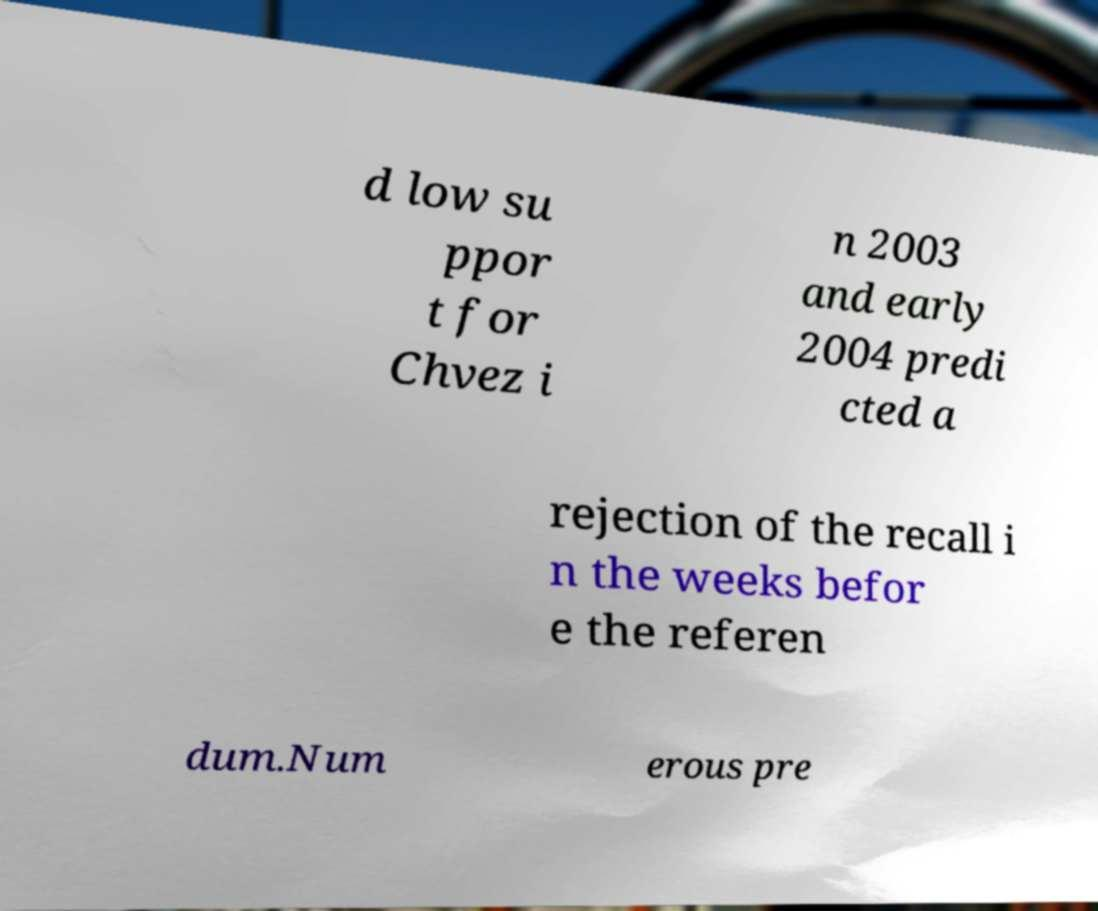Please identify and transcribe the text found in this image. d low su ppor t for Chvez i n 2003 and early 2004 predi cted a rejection of the recall i n the weeks befor e the referen dum.Num erous pre 